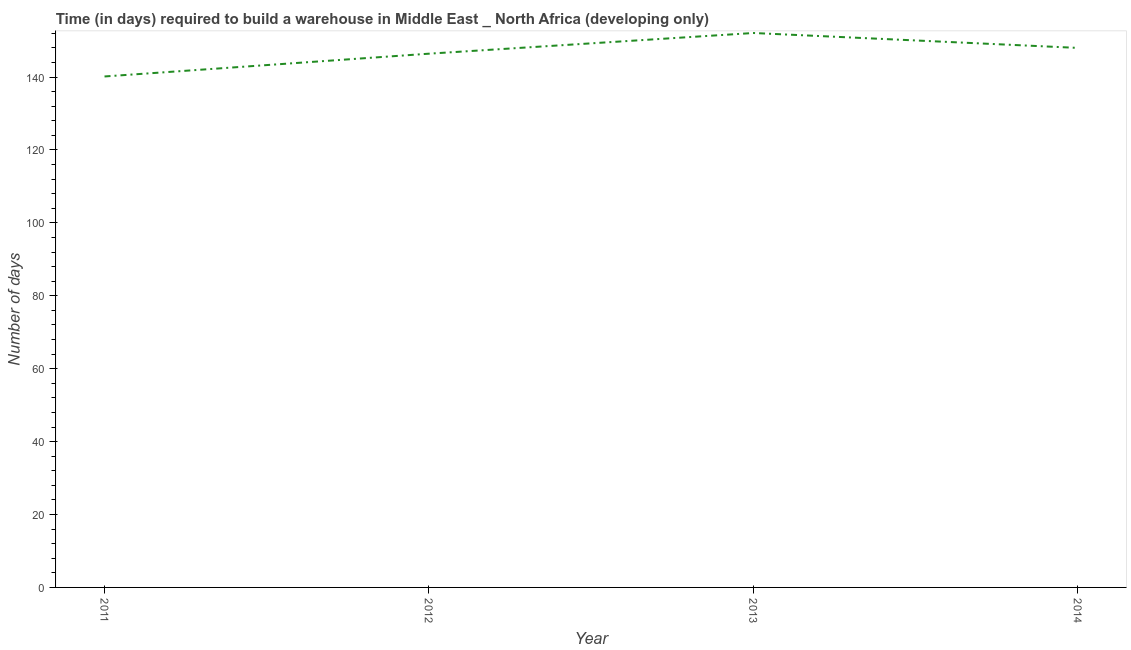What is the time required to build a warehouse in 2014?
Keep it short and to the point. 148. Across all years, what is the maximum time required to build a warehouse?
Provide a succinct answer. 152.09. Across all years, what is the minimum time required to build a warehouse?
Offer a terse response. 140.17. In which year was the time required to build a warehouse minimum?
Your response must be concise. 2011. What is the sum of the time required to build a warehouse?
Make the answer very short. 586.67. What is the difference between the time required to build a warehouse in 2011 and 2012?
Give a very brief answer. -6.25. What is the average time required to build a warehouse per year?
Offer a very short reply. 146.67. What is the median time required to build a warehouse?
Your response must be concise. 147.21. Do a majority of the years between 2012 and 2014 (inclusive) have time required to build a warehouse greater than 20 days?
Give a very brief answer. Yes. What is the ratio of the time required to build a warehouse in 2011 to that in 2013?
Give a very brief answer. 0.92. Is the time required to build a warehouse in 2013 less than that in 2014?
Provide a short and direct response. No. Is the difference between the time required to build a warehouse in 2012 and 2014 greater than the difference between any two years?
Keep it short and to the point. No. What is the difference between the highest and the second highest time required to build a warehouse?
Your answer should be very brief. 4.09. What is the difference between the highest and the lowest time required to build a warehouse?
Keep it short and to the point. 11.92. In how many years, is the time required to build a warehouse greater than the average time required to build a warehouse taken over all years?
Provide a short and direct response. 2. Does the time required to build a warehouse monotonically increase over the years?
Your answer should be compact. No. How many years are there in the graph?
Ensure brevity in your answer.  4. Are the values on the major ticks of Y-axis written in scientific E-notation?
Provide a short and direct response. No. What is the title of the graph?
Keep it short and to the point. Time (in days) required to build a warehouse in Middle East _ North Africa (developing only). What is the label or title of the X-axis?
Provide a succinct answer. Year. What is the label or title of the Y-axis?
Keep it short and to the point. Number of days. What is the Number of days of 2011?
Your answer should be compact. 140.17. What is the Number of days in 2012?
Provide a short and direct response. 146.42. What is the Number of days of 2013?
Ensure brevity in your answer.  152.09. What is the Number of days of 2014?
Offer a terse response. 148. What is the difference between the Number of days in 2011 and 2012?
Your response must be concise. -6.25. What is the difference between the Number of days in 2011 and 2013?
Keep it short and to the point. -11.92. What is the difference between the Number of days in 2011 and 2014?
Keep it short and to the point. -7.83. What is the difference between the Number of days in 2012 and 2013?
Ensure brevity in your answer.  -5.67. What is the difference between the Number of days in 2012 and 2014?
Your response must be concise. -1.58. What is the difference between the Number of days in 2013 and 2014?
Keep it short and to the point. 4.09. What is the ratio of the Number of days in 2011 to that in 2013?
Make the answer very short. 0.92. What is the ratio of the Number of days in 2011 to that in 2014?
Provide a short and direct response. 0.95. What is the ratio of the Number of days in 2012 to that in 2013?
Keep it short and to the point. 0.96. What is the ratio of the Number of days in 2012 to that in 2014?
Make the answer very short. 0.99. What is the ratio of the Number of days in 2013 to that in 2014?
Your response must be concise. 1.03. 